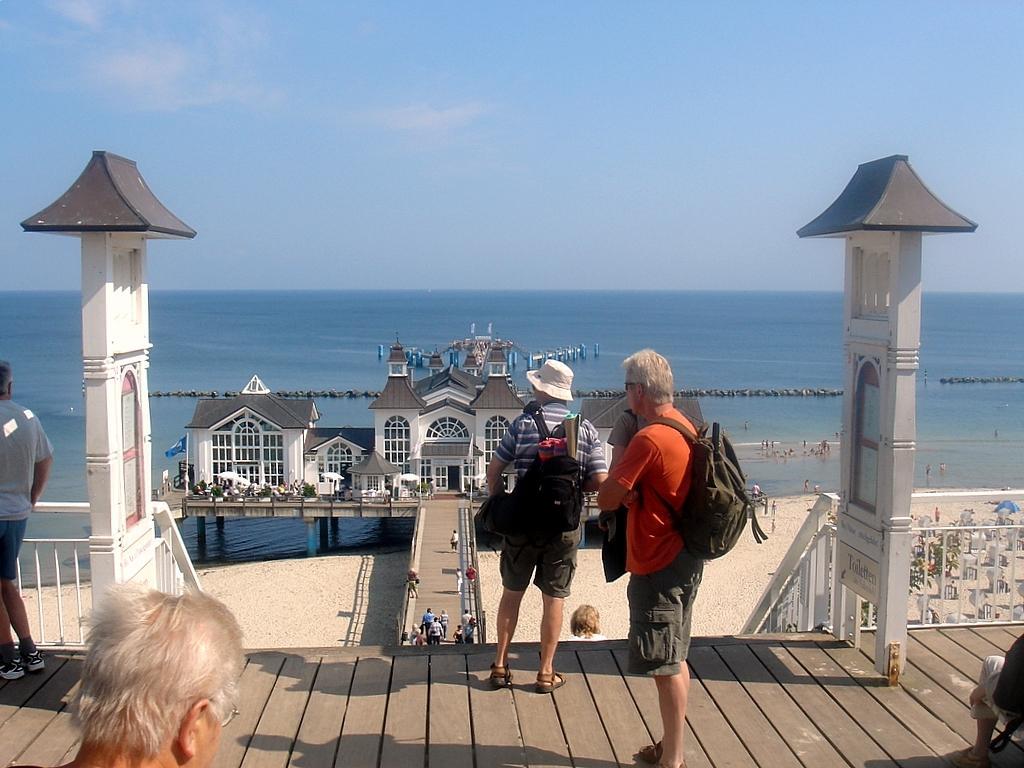Please provide a concise description of this image. This is a picture of a beach. The water is in blue color. Sky is in blue color. This is a bridge to travel from this end to that end. This is house. It is in white and ash color with a windows. The man is standing in orange t-shirt is carrying a bag. The man is standing here wore a cap and carrying a black bag. 